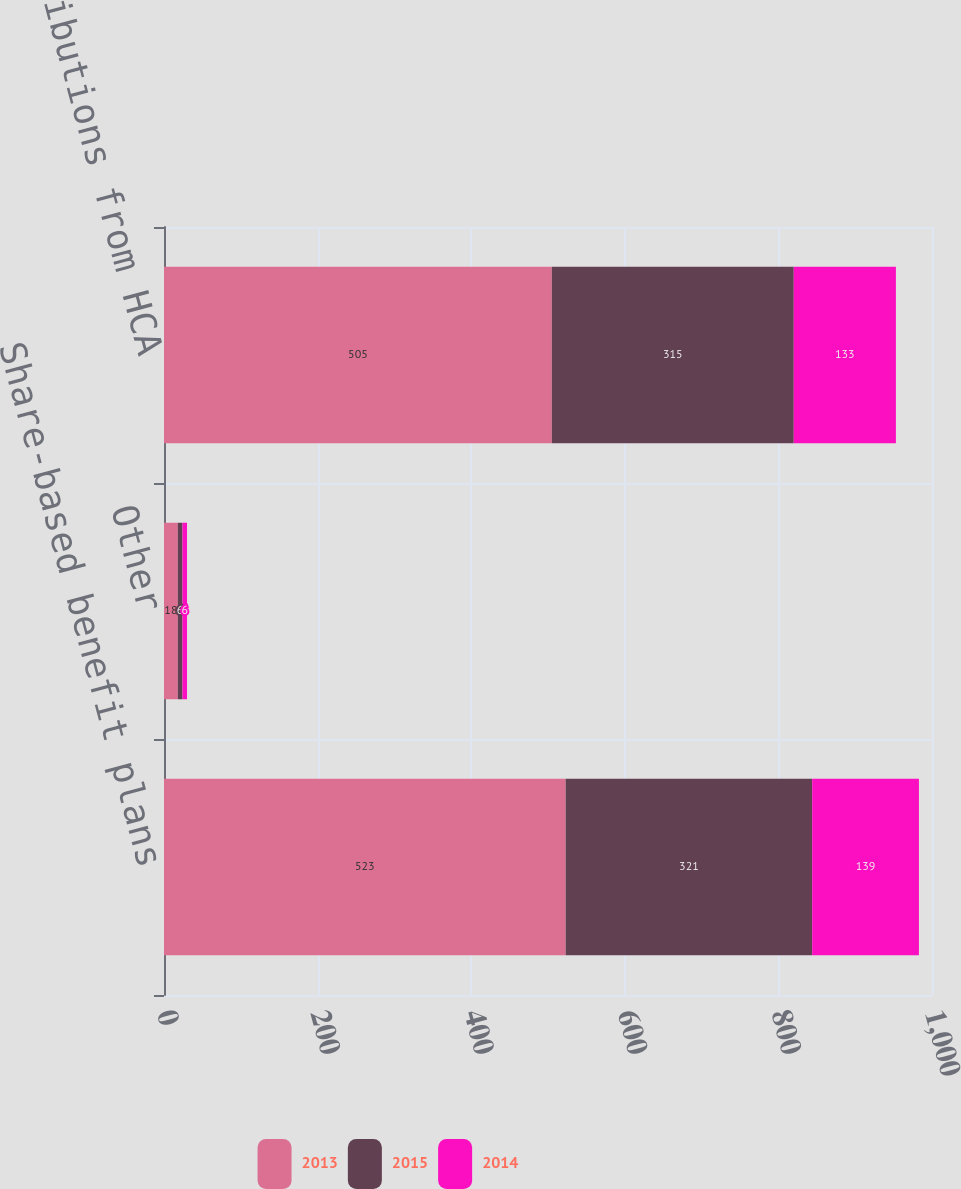Convert chart. <chart><loc_0><loc_0><loc_500><loc_500><stacked_bar_chart><ecel><fcel>Share-based benefit plans<fcel>Other<fcel>Distributions from HCA<nl><fcel>2013<fcel>523<fcel>18<fcel>505<nl><fcel>2015<fcel>321<fcel>6<fcel>315<nl><fcel>2014<fcel>139<fcel>6<fcel>133<nl></chart> 